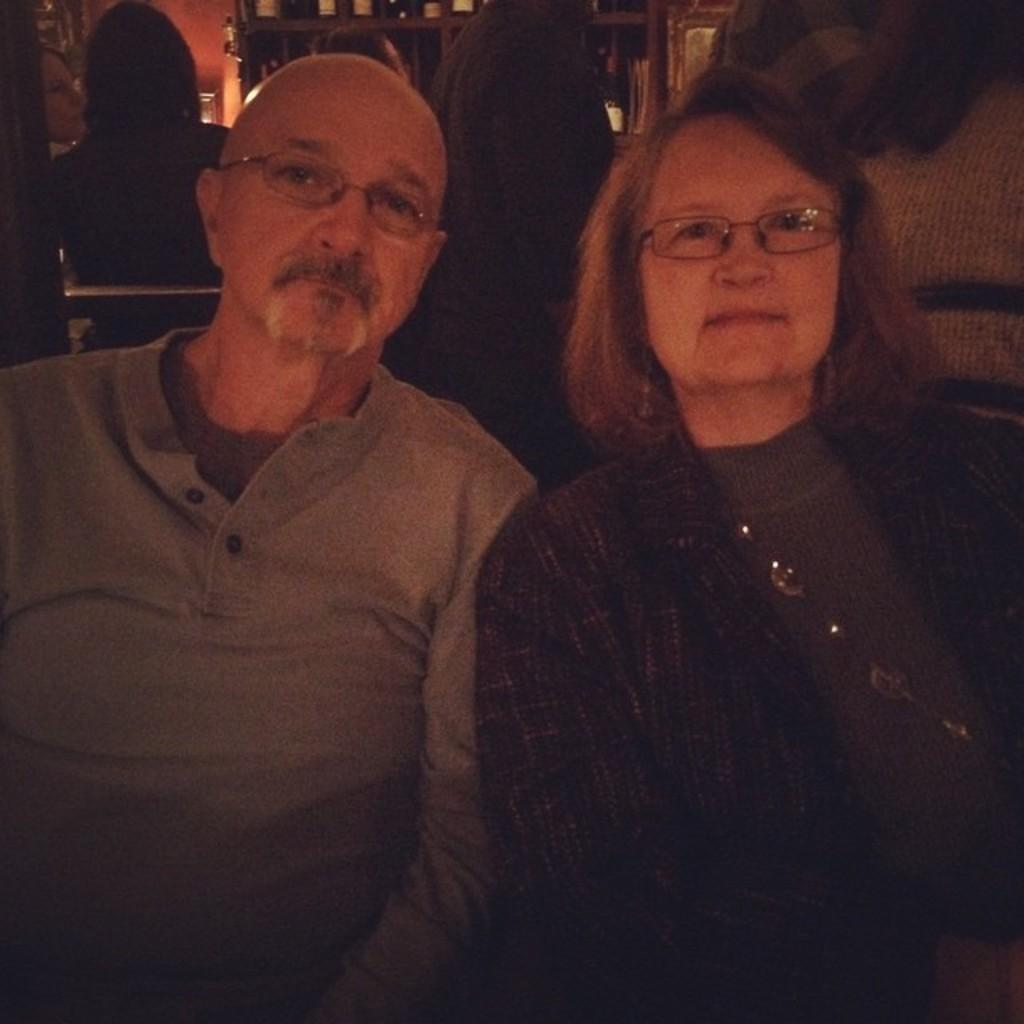How many people can be seen in the image? There are a few people in the image. What can be seen in the background of the image? There are shelves with objects in the background of the image. What is visible on one side of the image? There is a wall visible in the image. What type of volcano can be seen erupting in the background of the image? There is no volcano present in the image; it only features people, shelves with objects, and a wall. 